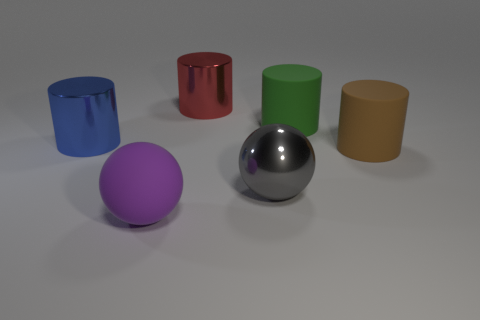What is the shape of the metallic object to the right of the red cylinder?
Keep it short and to the point. Sphere. Is the big purple thing made of the same material as the big sphere behind the large purple rubber object?
Offer a terse response. No. Does the big brown rubber object have the same shape as the green rubber object?
Provide a short and direct response. Yes. There is a gray object that is the same shape as the purple object; what is its material?
Offer a very short reply. Metal. There is a cylinder that is both on the right side of the red metallic thing and behind the blue shiny object; what is its color?
Keep it short and to the point. Green. What color is the metal ball?
Offer a very short reply. Gray. Are there any large gray metal things that have the same shape as the big green matte object?
Provide a succinct answer. No. There is a green cylinder that is the same size as the red object; what is it made of?
Ensure brevity in your answer.  Rubber. Are there more large green matte things than small cyan rubber balls?
Offer a very short reply. Yes. What is the shape of the green object that is the same size as the brown matte thing?
Your answer should be very brief. Cylinder. 